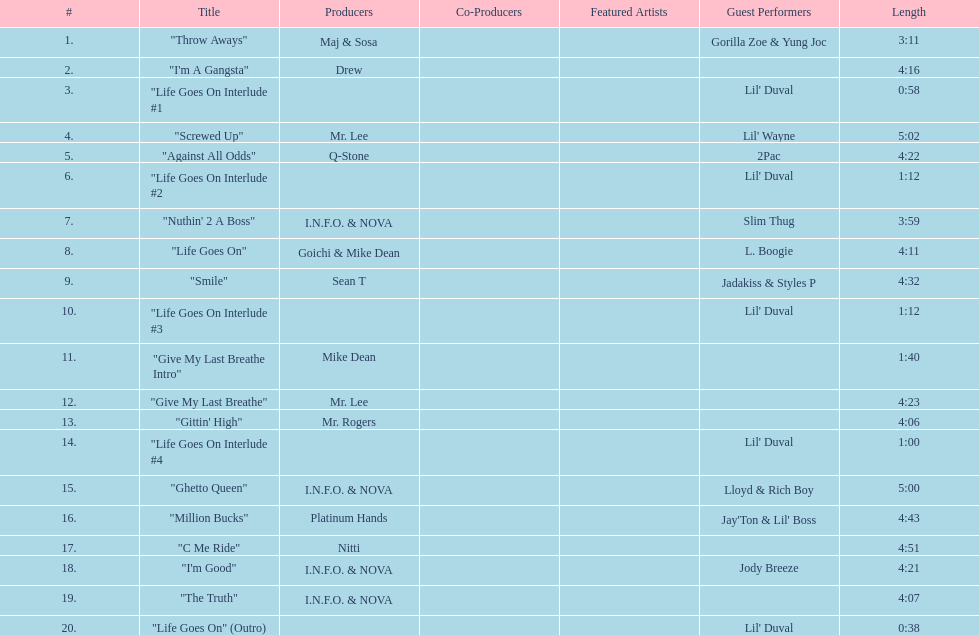What is the total number of tracks on the album? 20. 